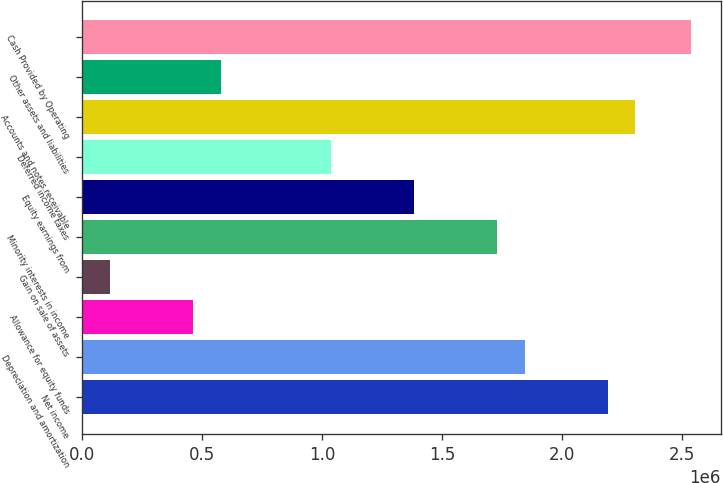Convert chart to OTSL. <chart><loc_0><loc_0><loc_500><loc_500><bar_chart><fcel>Net income<fcel>Depreciation and amortization<fcel>Allowance for equity funds<fcel>Gain on sale of assets<fcel>Minority interests in income<fcel>Equity earnings from<fcel>Deferred income taxes<fcel>Accounts and notes receivable<fcel>Other assets and liabilities<fcel>Cash Provided by Operating<nl><fcel>2.18824e+06<fcel>1.84275e+06<fcel>460816<fcel>115331<fcel>1.72759e+06<fcel>1.38211e+06<fcel>1.03662e+06<fcel>2.3034e+06<fcel>575977<fcel>2.53372e+06<nl></chart> 